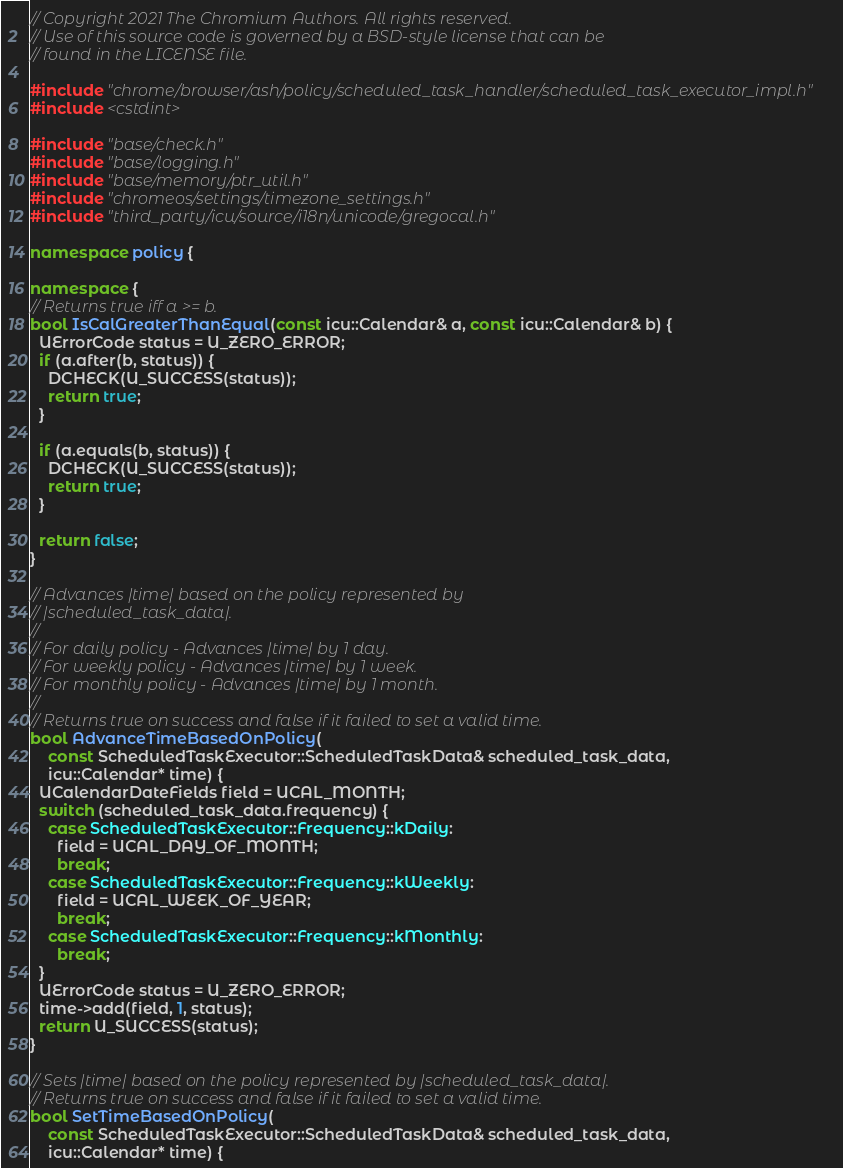<code> <loc_0><loc_0><loc_500><loc_500><_C++_>// Copyright 2021 The Chromium Authors. All rights reserved.
// Use of this source code is governed by a BSD-style license that can be
// found in the LICENSE file.

#include "chrome/browser/ash/policy/scheduled_task_handler/scheduled_task_executor_impl.h"
#include <cstdint>

#include "base/check.h"
#include "base/logging.h"
#include "base/memory/ptr_util.h"
#include "chromeos/settings/timezone_settings.h"
#include "third_party/icu/source/i18n/unicode/gregocal.h"

namespace policy {

namespace {
// Returns true iff a >= b.
bool IsCalGreaterThanEqual(const icu::Calendar& a, const icu::Calendar& b) {
  UErrorCode status = U_ZERO_ERROR;
  if (a.after(b, status)) {
    DCHECK(U_SUCCESS(status));
    return true;
  }

  if (a.equals(b, status)) {
    DCHECK(U_SUCCESS(status));
    return true;
  }

  return false;
}

// Advances |time| based on the policy represented by
// |scheduled_task_data|.
//
// For daily policy - Advances |time| by 1 day.
// For weekly policy - Advances |time| by 1 week.
// For monthly policy - Advances |time| by 1 month.
//
// Returns true on success and false if it failed to set a valid time.
bool AdvanceTimeBasedOnPolicy(
    const ScheduledTaskExecutor::ScheduledTaskData& scheduled_task_data,
    icu::Calendar* time) {
  UCalendarDateFields field = UCAL_MONTH;
  switch (scheduled_task_data.frequency) {
    case ScheduledTaskExecutor::Frequency::kDaily:
      field = UCAL_DAY_OF_MONTH;
      break;
    case ScheduledTaskExecutor::Frequency::kWeekly:
      field = UCAL_WEEK_OF_YEAR;
      break;
    case ScheduledTaskExecutor::Frequency::kMonthly:
      break;
  }
  UErrorCode status = U_ZERO_ERROR;
  time->add(field, 1, status);
  return U_SUCCESS(status);
}

// Sets |time| based on the policy represented by |scheduled_task_data|.
// Returns true on success and false if it failed to set a valid time.
bool SetTimeBasedOnPolicy(
    const ScheduledTaskExecutor::ScheduledTaskData& scheduled_task_data,
    icu::Calendar* time) {</code> 